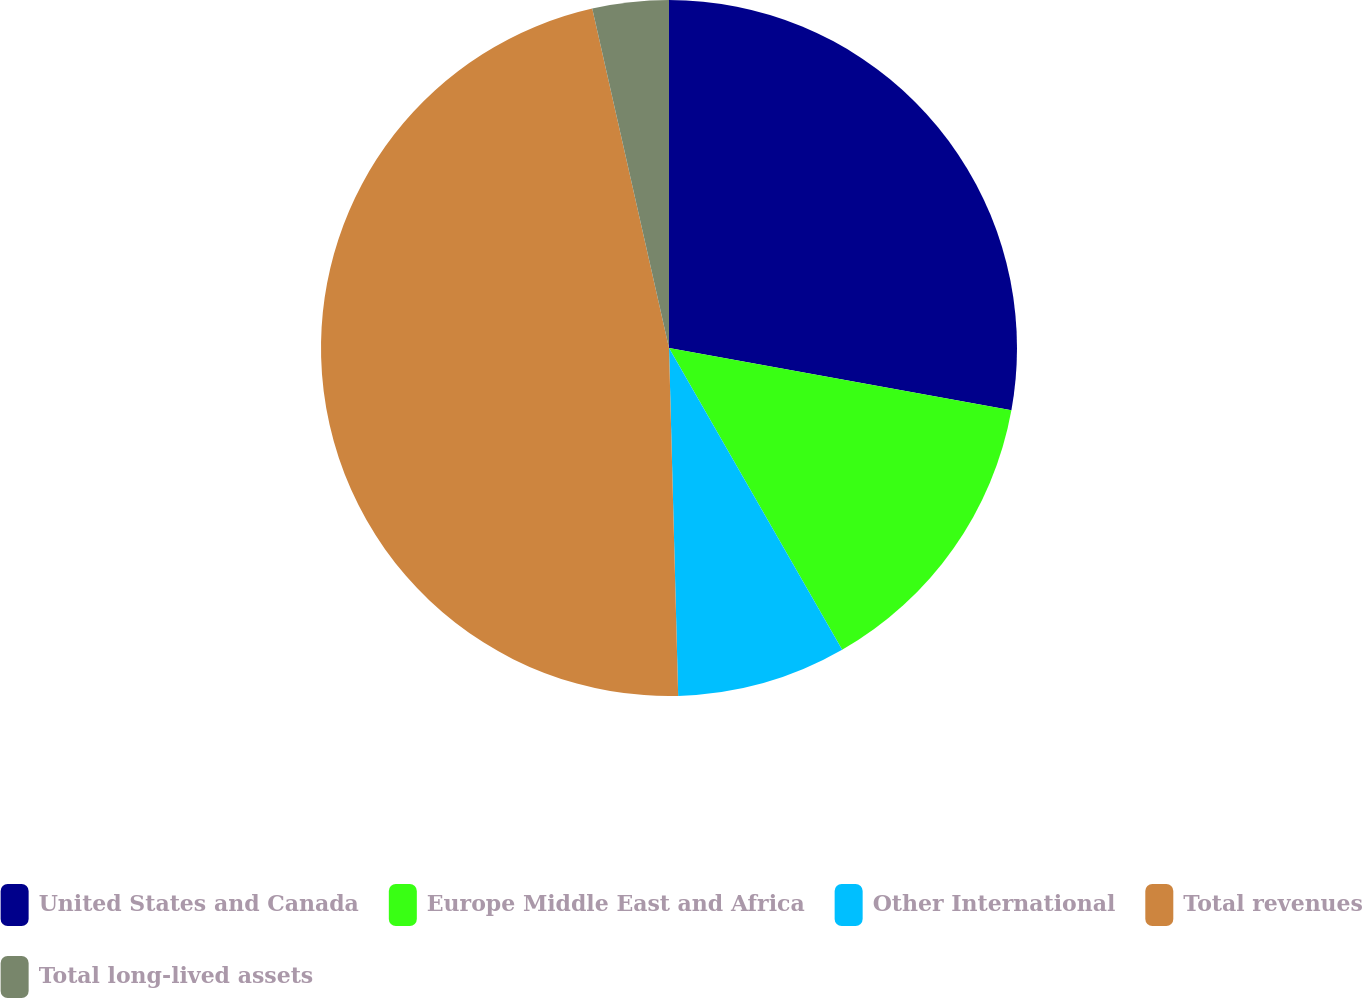Convert chart. <chart><loc_0><loc_0><loc_500><loc_500><pie_chart><fcel>United States and Canada<fcel>Europe Middle East and Africa<fcel>Other International<fcel>Total revenues<fcel>Total long-lived assets<nl><fcel>27.86%<fcel>13.85%<fcel>7.87%<fcel>46.88%<fcel>3.54%<nl></chart> 